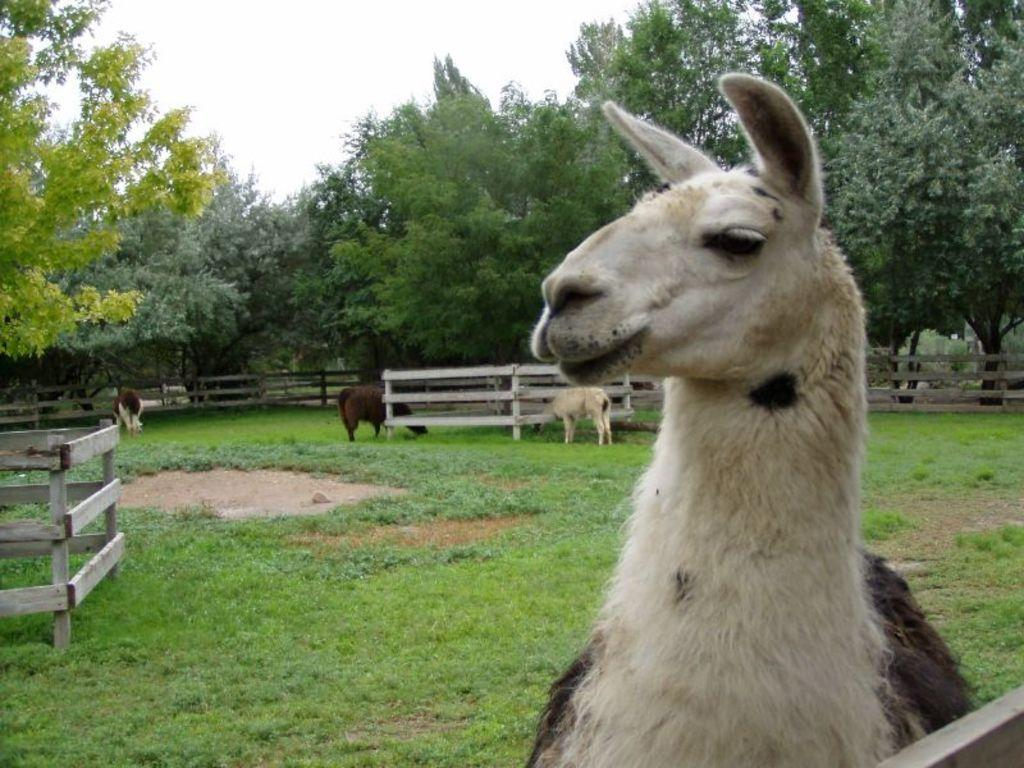What animal is located on the right side of the image? There is a goat on the right side of the image. What other animals can be seen in the image? There are animals in the background of the image. What separates the goat from the background? There is a fence visible in the image. What type of vegetation is visible in the background? There are trees in the background of the image. What is visible at the top of the image? The sky is visible at the top of the image. What finger is the goat using to point at the noise in the image? There is no noise or finger present in the image; it features a goat and other animals in a natural setting. 